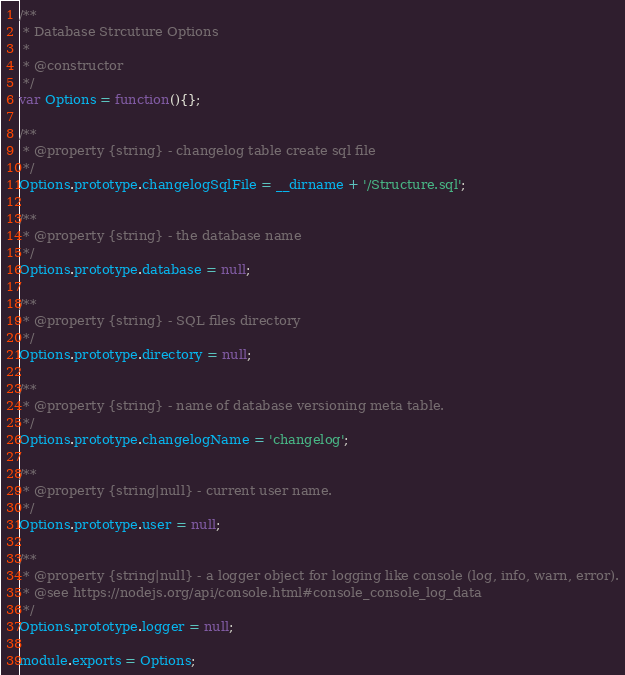Convert code to text. <code><loc_0><loc_0><loc_500><loc_500><_JavaScript_>/**
 * Database Strcuture Options
 *
 * @constructor
 */
var Options = function(){};

/**
 * @property {string} - changelog table create sql file
 */
Options.prototype.changelogSqlFile = __dirname + '/Structure.sql';

/**
 * @property {string} - the database name
 */
Options.prototype.database = null;

/**
 * @property {string} - SQL files directory
 */
Options.prototype.directory = null;

/**
 * @property {string} - name of database versioning meta table.
 */
Options.prototype.changelogName = 'changelog';

/**
 * @property {string|null} - current user name.
 */
Options.prototype.user = null;

/**
 * @property {string|null} - a logger object for logging like console (log, info, warn, error).
 * @see https://nodejs.org/api/console.html#console_console_log_data
 */
Options.prototype.logger = null;

module.exports = Options;
</code> 